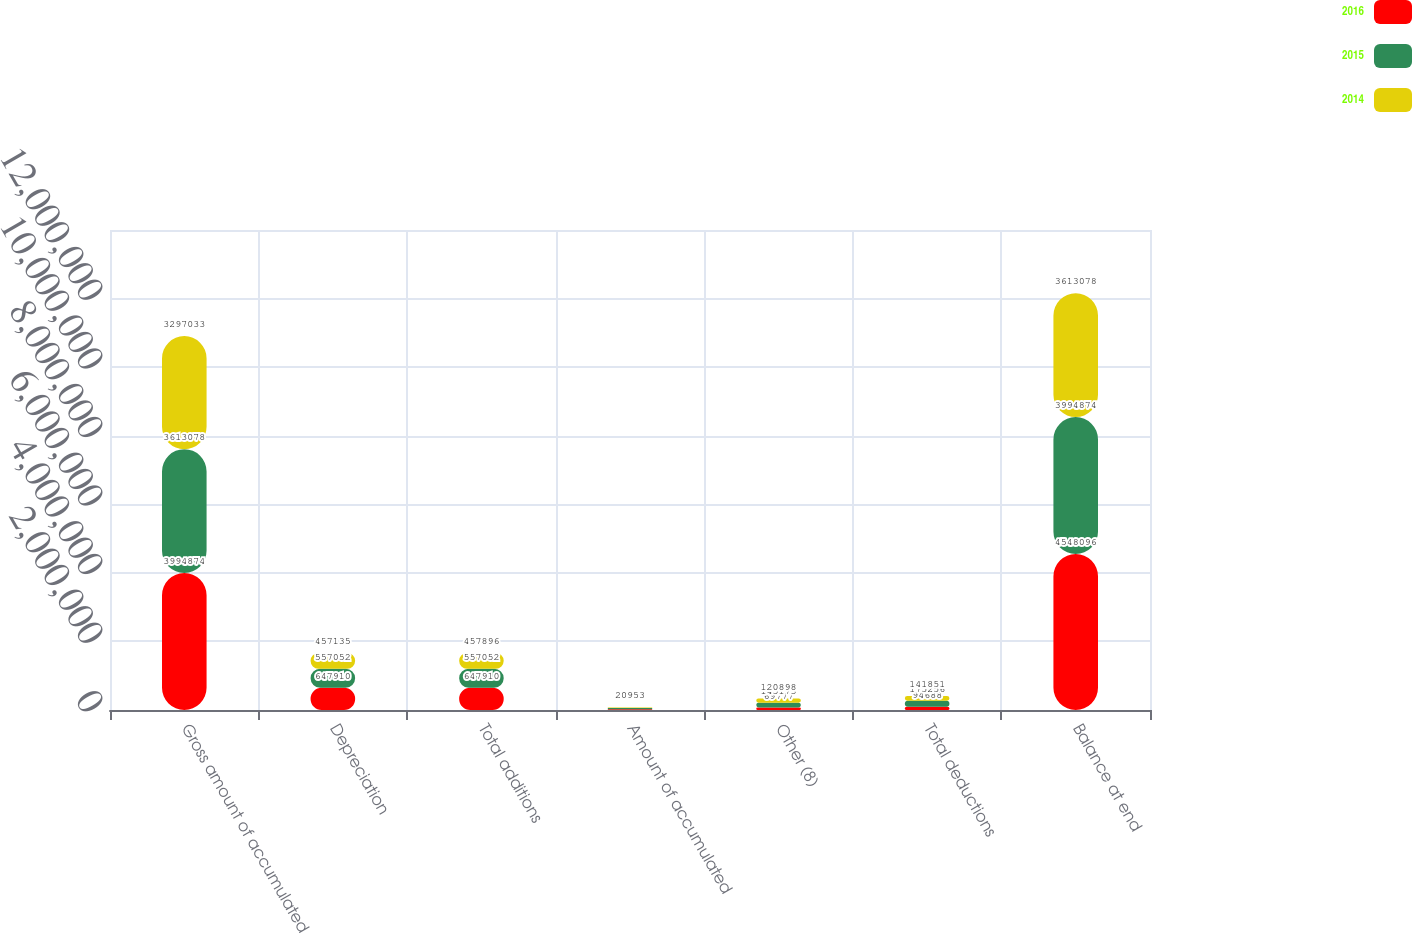Convert chart. <chart><loc_0><loc_0><loc_500><loc_500><stacked_bar_chart><ecel><fcel>Gross amount of accumulated<fcel>Depreciation<fcel>Total additions<fcel>Amount of accumulated<fcel>Other (8)<fcel>Total deductions<fcel>Balance at end<nl><fcel>2016<fcel>3.99487e+06<fcel>647910<fcel>647910<fcel>24911<fcel>69777<fcel>94688<fcel>4.5481e+06<nl><fcel>2015<fcel>3.61308e+06<fcel>557052<fcel>557052<fcel>30083<fcel>145173<fcel>175256<fcel>3.99487e+06<nl><fcel>2014<fcel>3.29703e+06<fcel>457135<fcel>457896<fcel>20953<fcel>120898<fcel>141851<fcel>3.61308e+06<nl></chart> 